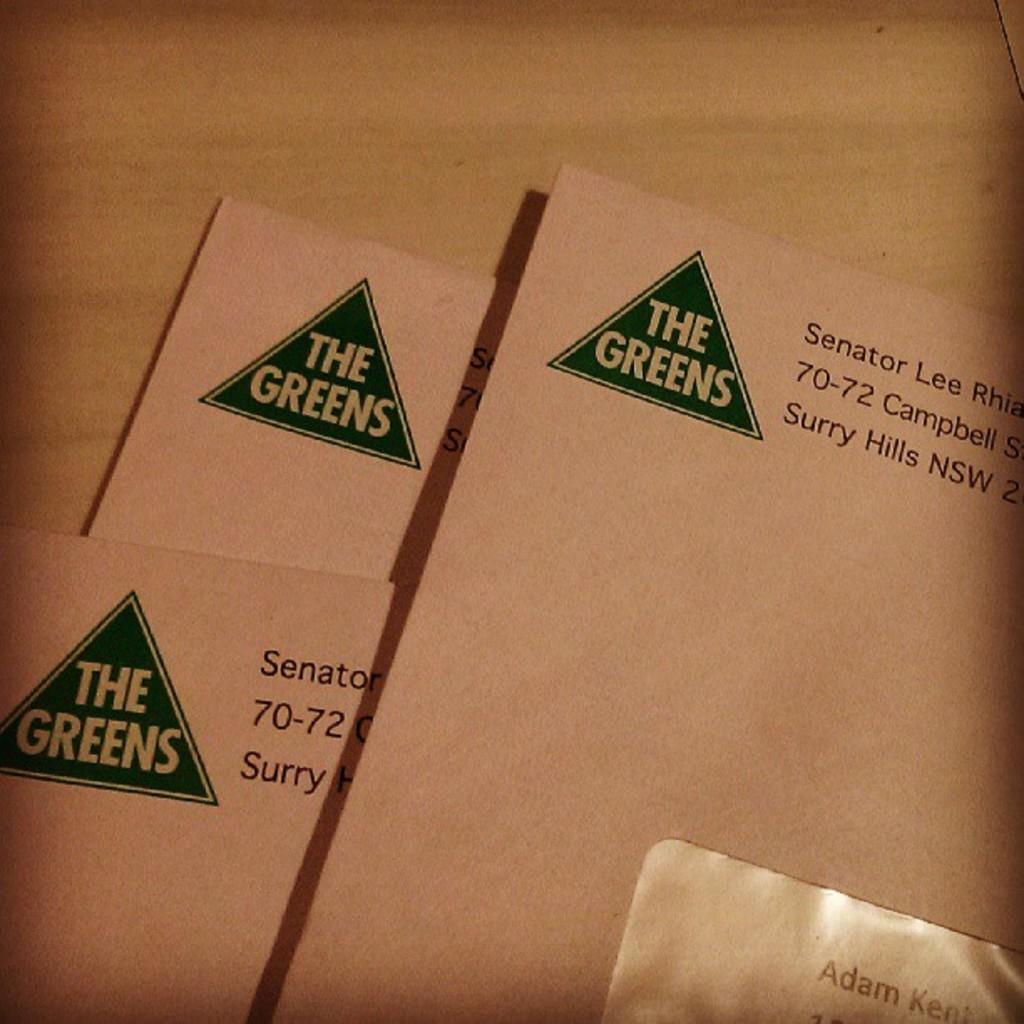What is the name of the company?
Ensure brevity in your answer.  The greens. What is the name on the paper by the triangle?
Give a very brief answer. The greens. 